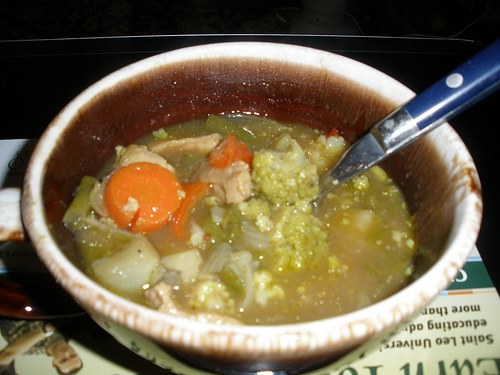What types of vegetables can you identify in the soup? The soup contains identifiable vegetables such as carrots, onions, and broccoli. 